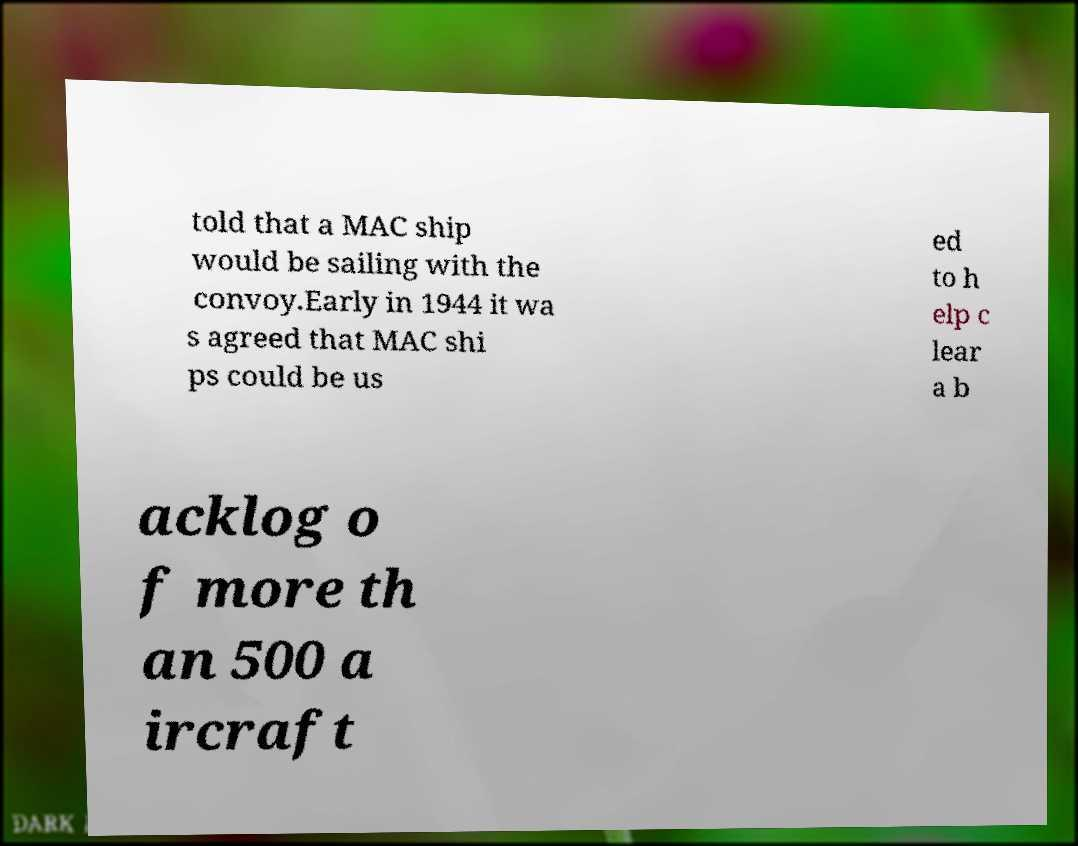There's text embedded in this image that I need extracted. Can you transcribe it verbatim? told that a MAC ship would be sailing with the convoy.Early in 1944 it wa s agreed that MAC shi ps could be us ed to h elp c lear a b acklog o f more th an 500 a ircraft 